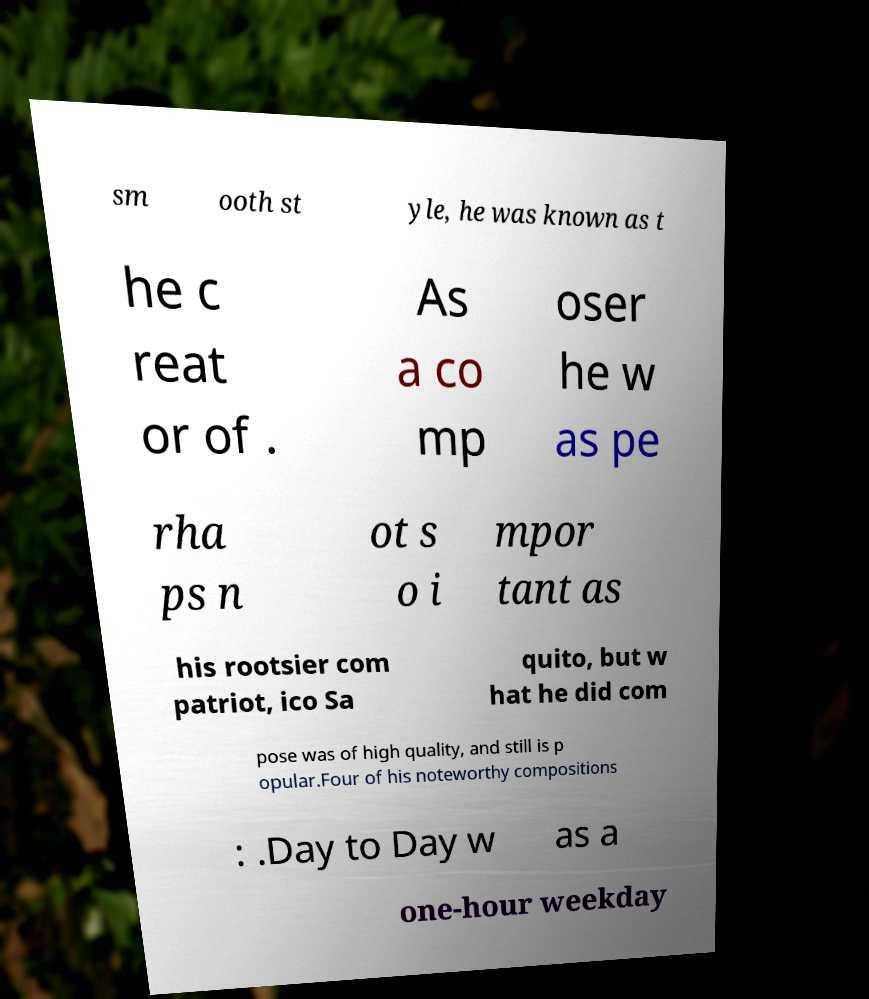Could you assist in decoding the text presented in this image and type it out clearly? sm ooth st yle, he was known as t he c reat or of . As a co mp oser he w as pe rha ps n ot s o i mpor tant as his rootsier com patriot, ico Sa quito, but w hat he did com pose was of high quality, and still is p opular.Four of his noteworthy compositions : .Day to Day w as a one-hour weekday 